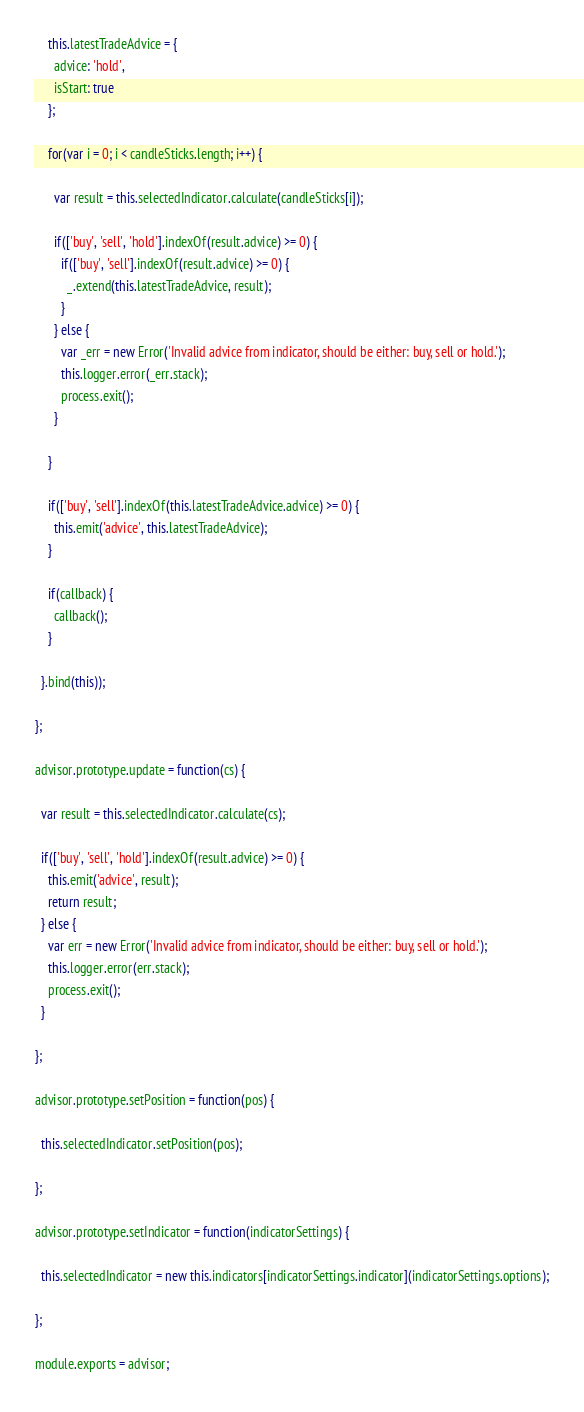Convert code to text. <code><loc_0><loc_0><loc_500><loc_500><_JavaScript_>
    this.latestTradeAdvice = {
      advice: 'hold',
      isStart: true
    };

    for(var i = 0; i < candleSticks.length; i++) {

      var result = this.selectedIndicator.calculate(candleSticks[i]);

      if(['buy', 'sell', 'hold'].indexOf(result.advice) >= 0) {
        if(['buy', 'sell'].indexOf(result.advice) >= 0) {
          _.extend(this.latestTradeAdvice, result);
        }
      } else {
        var _err = new Error('Invalid advice from indicator, should be either: buy, sell or hold.');
        this.logger.error(_err.stack);
        process.exit();
      }

    }

    if(['buy', 'sell'].indexOf(this.latestTradeAdvice.advice) >= 0) {
      this.emit('advice', this.latestTradeAdvice);
    }

    if(callback) {
      callback();
    }

  }.bind(this));

};

advisor.prototype.update = function(cs) {

  var result = this.selectedIndicator.calculate(cs);

  if(['buy', 'sell', 'hold'].indexOf(result.advice) >= 0) {
    this.emit('advice', result);
    return result;
  } else {
    var err = new Error('Invalid advice from indicator, should be either: buy, sell or hold.');
    this.logger.error(err.stack);
    process.exit();
  }

};

advisor.prototype.setPosition = function(pos) {

  this.selectedIndicator.setPosition(pos);

};

advisor.prototype.setIndicator = function(indicatorSettings) {

  this.selectedIndicator = new this.indicators[indicatorSettings.indicator](indicatorSettings.options);

};

module.exports = advisor;
</code> 